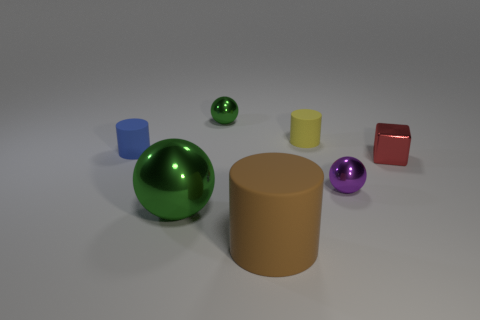There is a cylinder that is left of the tiny metal thing that is behind the small red shiny cube; how big is it?
Provide a succinct answer. Small. Is the color of the large metal object the same as the cylinder that is in front of the tiny purple metallic sphere?
Offer a very short reply. No. How many other things are made of the same material as the purple ball?
Make the answer very short. 3. What shape is the brown thing that is made of the same material as the yellow object?
Ensure brevity in your answer.  Cylinder. Are there any other things that are the same color as the small metallic cube?
Offer a terse response. No. There is another thing that is the same color as the big shiny thing; what size is it?
Provide a succinct answer. Small. Is the number of large green shiny things that are to the right of the large green shiny sphere greater than the number of big green objects?
Provide a short and direct response. No. There is a large brown matte object; is it the same shape as the green metallic thing behind the purple ball?
Make the answer very short. No. What number of yellow matte objects have the same size as the shiny block?
Your answer should be very brief. 1. How many big brown objects are behind the green shiny thing that is behind the tiny metal ball that is in front of the tiny blue cylinder?
Your answer should be very brief. 0. 